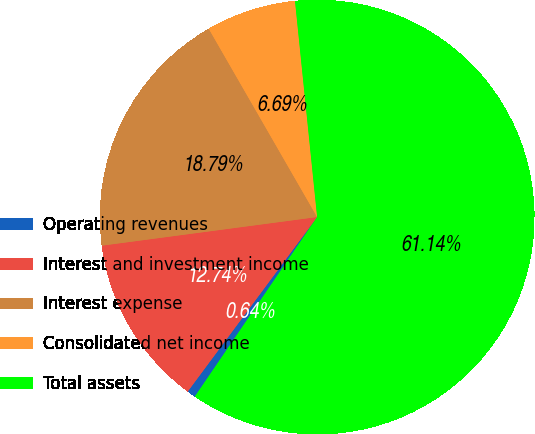<chart> <loc_0><loc_0><loc_500><loc_500><pie_chart><fcel>Operating revenues<fcel>Interest and investment income<fcel>Interest expense<fcel>Consolidated net income<fcel>Total assets<nl><fcel>0.64%<fcel>12.74%<fcel>18.79%<fcel>6.69%<fcel>61.15%<nl></chart> 